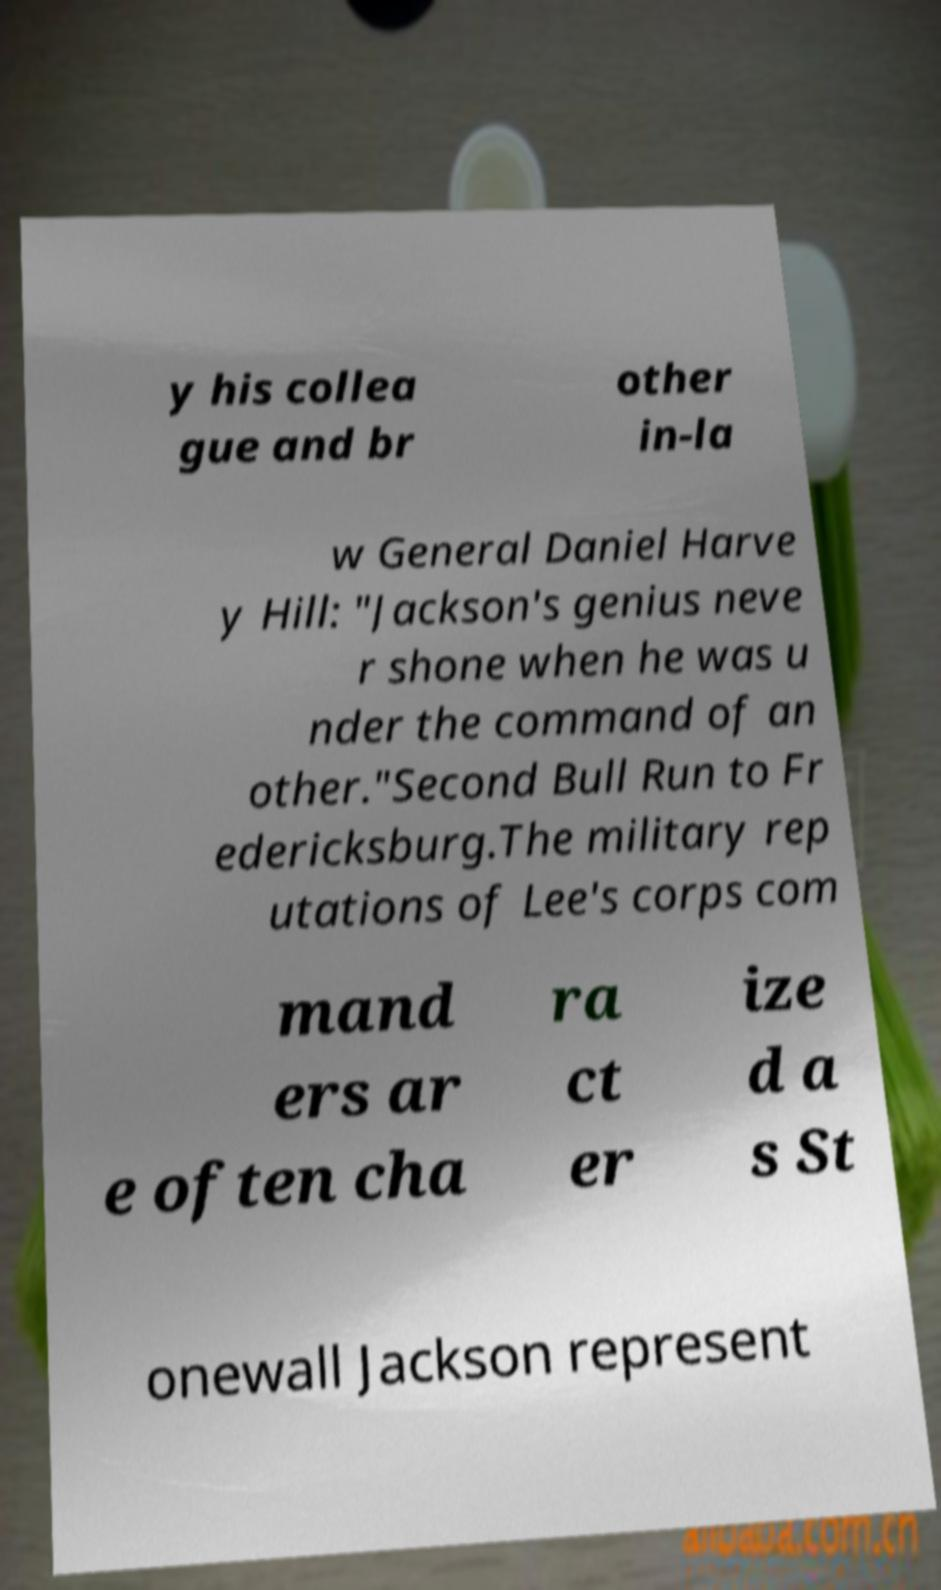Can you accurately transcribe the text from the provided image for me? y his collea gue and br other in-la w General Daniel Harve y Hill: "Jackson's genius neve r shone when he was u nder the command of an other."Second Bull Run to Fr edericksburg.The military rep utations of Lee's corps com mand ers ar e often cha ra ct er ize d a s St onewall Jackson represent 